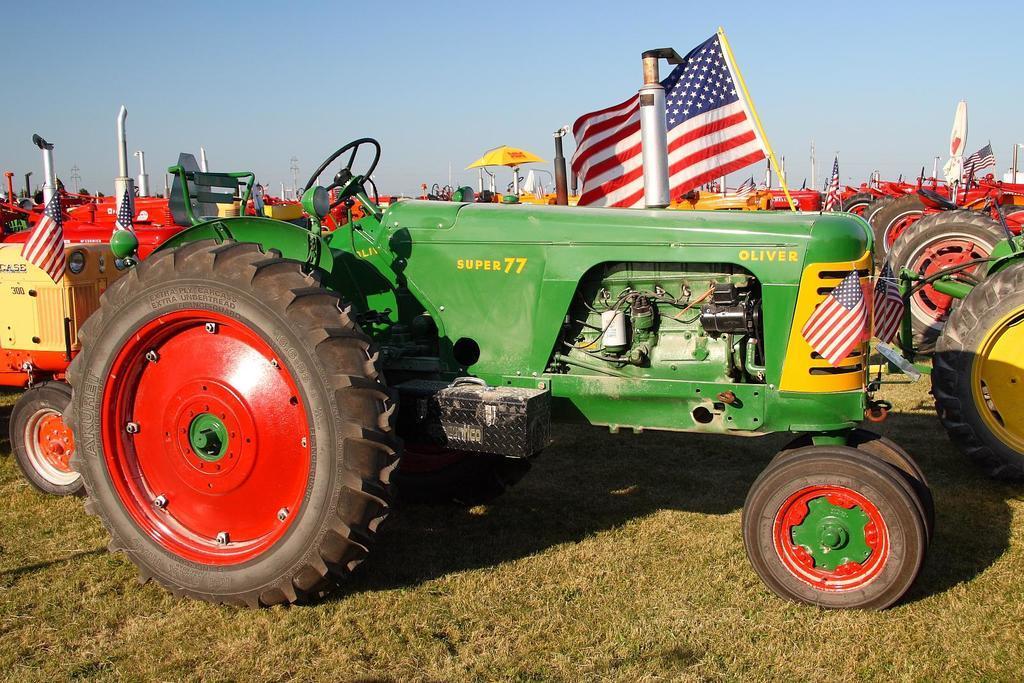In one or two sentences, can you explain what this image depicts? In the picture we can see a tractor on the grass surface and behind it, we can see some other tractors and in the background we can see the sky. 